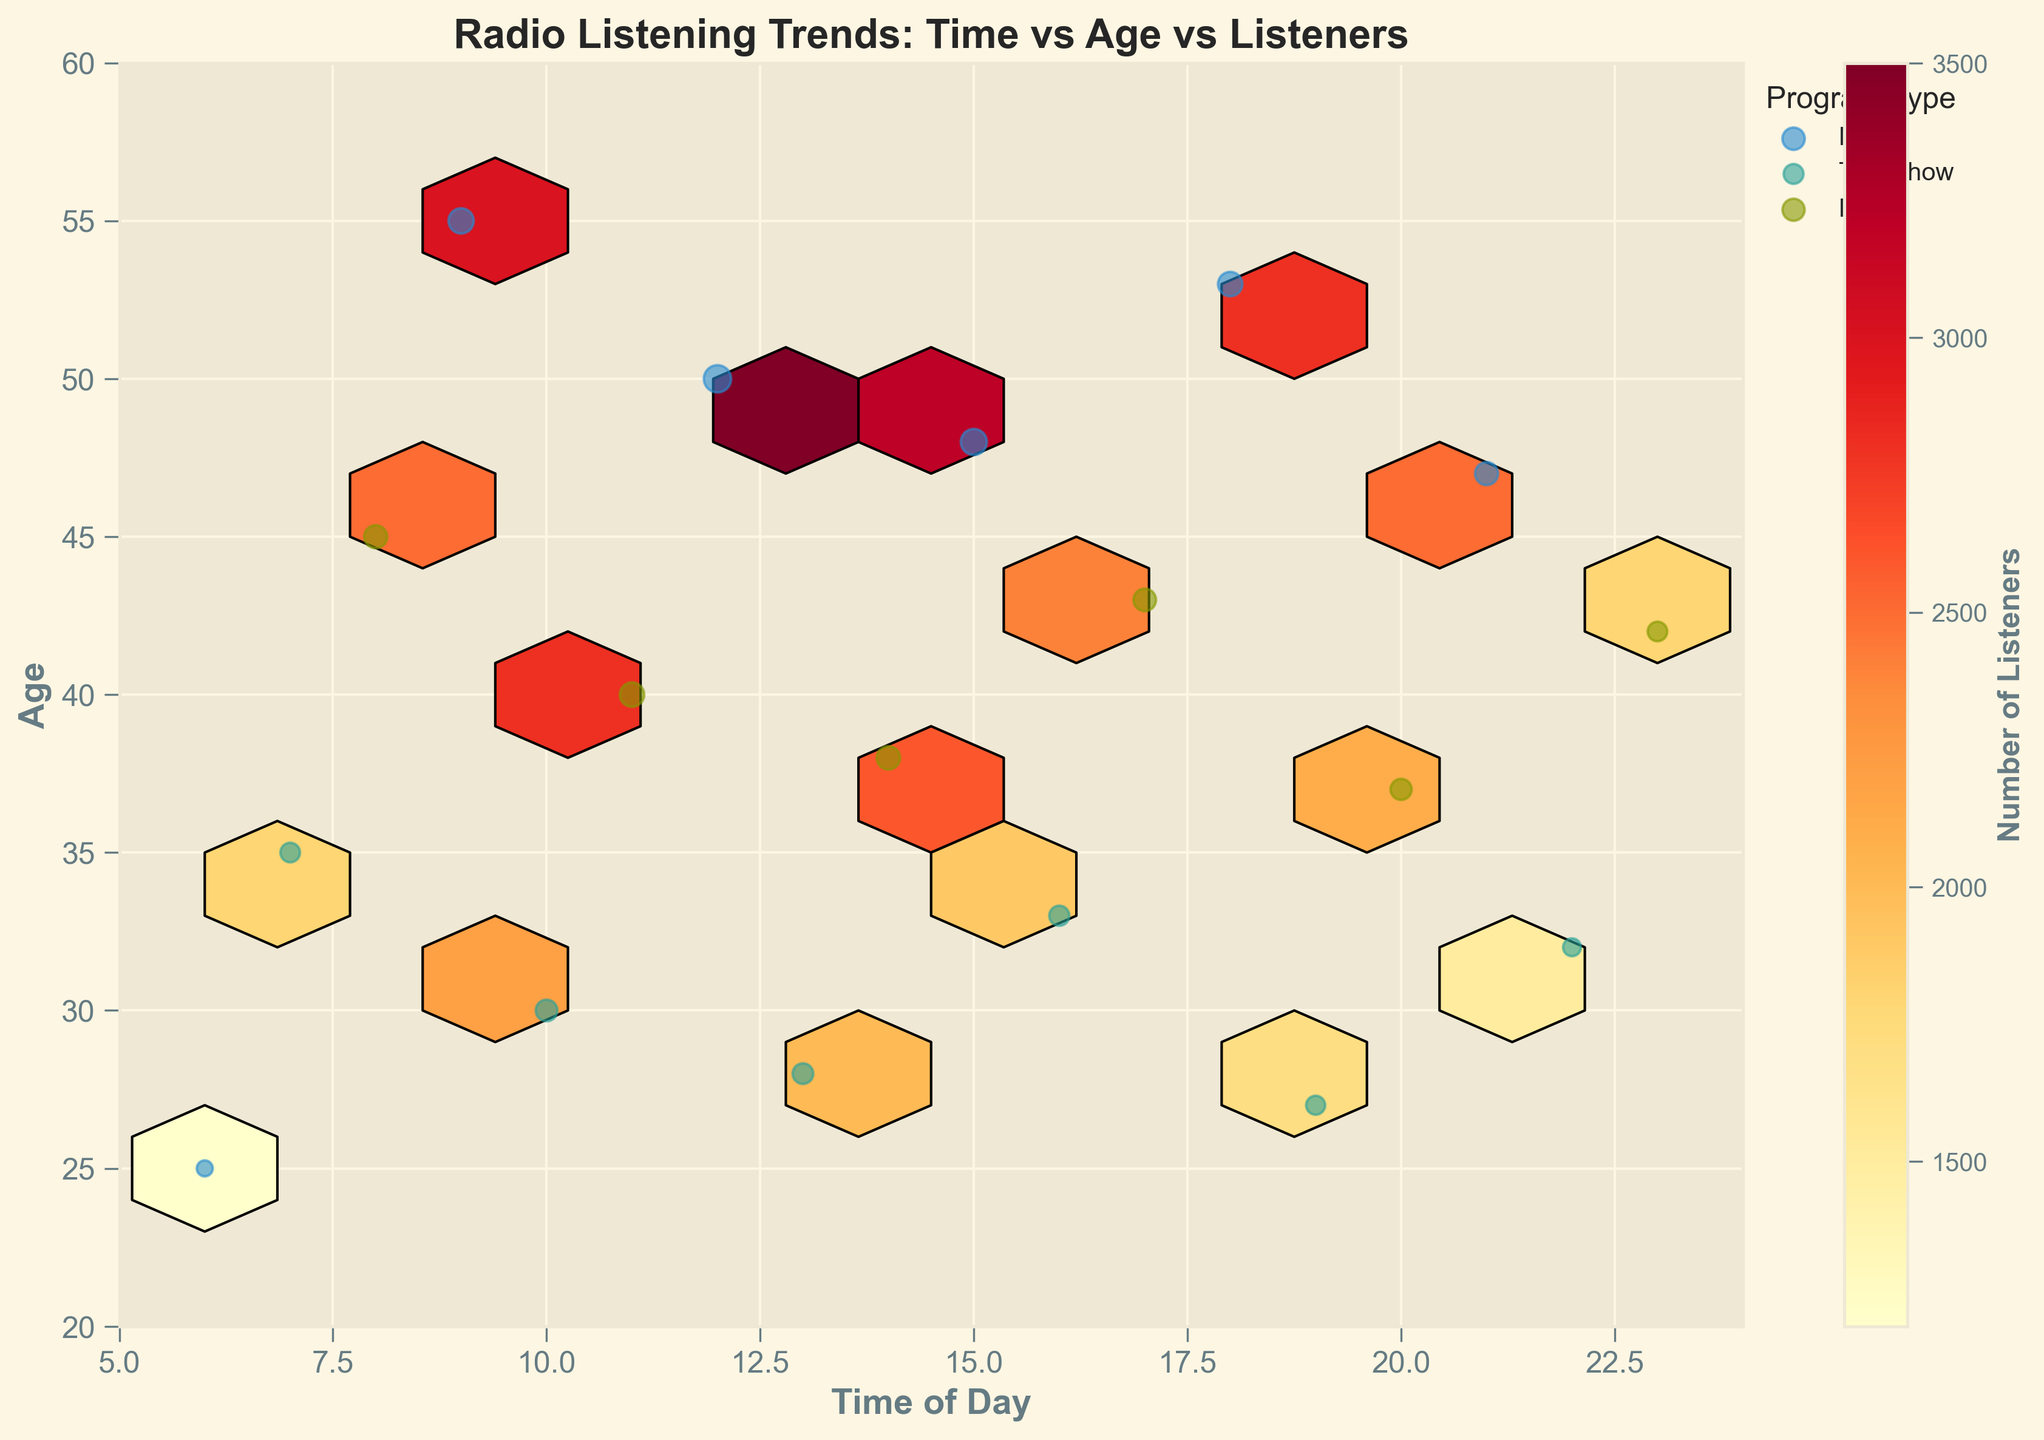What is the title of the plot? The title is displayed at the top of the figure and summarizes what the plot represents. According to the information, it is "Radio Listening Trends: Time vs Age vs Listeners"
Answer: Radio Listening Trends: Time vs Age vs Listeners Which axes represent time of day and age? The axis labels provide this information. According to the data, the x-axis represents 'Time of Day' and the y-axis represents 'Age'.
Answer: x-axis: Time of Day, y-axis: Age What does the color bar represent? The color bar's label indicates what it represents. According to the plot setup, it represents the number of listeners.
Answer: Number of listeners At what time of day and age group is the highest concentration of listeners? We look for the densest area in the hexbin plot with the most intense (darkest) color indicating the highest listener concentration.
Answer: 12 PM, 50 years old Which program type tends to have the highest number of listeners based on the scatter points? We compare the scatter points sizes for each program type, noting the size relates to the number of listeners. According to the information, 'News' tends to have larger scatter points, indicating more listeners.
Answer: News How does listener age vary between talk shows at 7 AM and 4 PM? By locating scatter points at 7 AM and 4 PM for 'Talk Show', we compare the vertical positions representing age.
Answer: 35 years (7 AM), 33 years (4 PM) Which time slots between 6 AM and 12 PM show an increasing trend in listener count for news programs? We track the scatter points size for 'News' between 6 AM and 12 PM, noting any increase in size which indicates a trend in listener count.
Answer: Increase from 6 AM to 12 PM In which time slot can we see the largest audience shift from music to news? By checking scatter points of 'Music' and 'News' with noticeable differences in sizes, we identify time slots with a noticeable audience shift.
Answer: 9 AM to 10 AM What age group prefers music programs the most around midday? We check the scatter points for 'Music' around midday (11 AM to 1 PM) and identify the vertical positions, representing age, that show the largest scatter points.
Answer: 40 years old How does the listeners' age distribution look for News programs between 9 AM and 10 AM? By analyzing the scatter points for 'News' between 9 AM and 10 AM, we observe their vertical positions, representing the age distribution.
Answer: 55 years old and 30 years old 